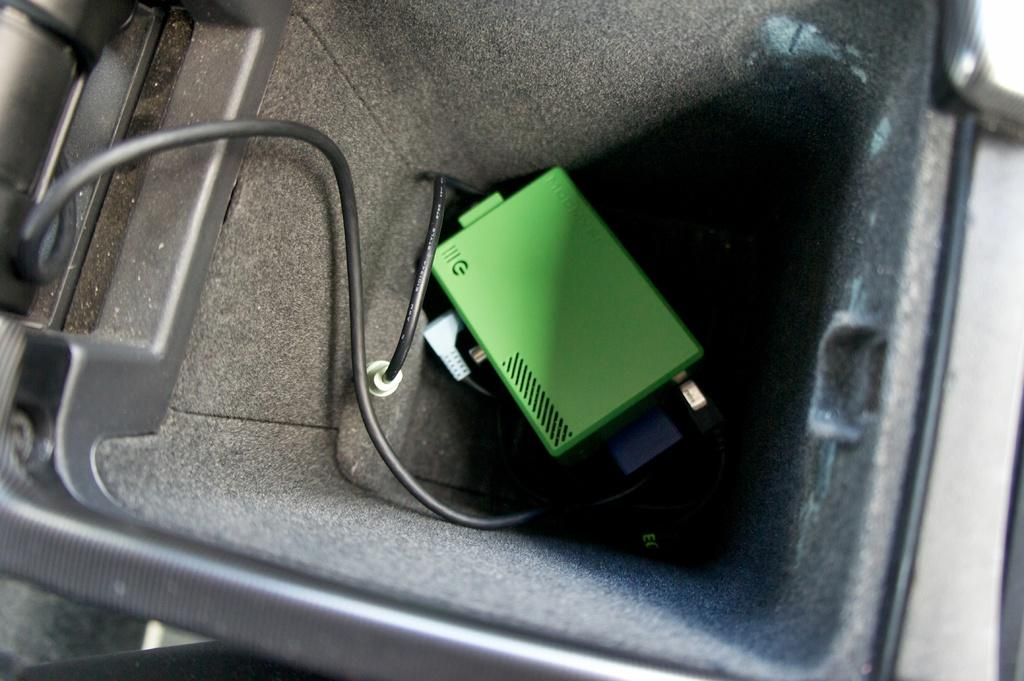What color is the object that is visible in the image? The object in the image is green. How is the green object contained or held in the image? The green object is placed in a square-shaped container. What type of items can be seen in the image besides the green object? There are cables in the image. How does the green object grow in the image? The green object does not grow in the image; it is a static object placed in a container. What type of magic is being performed with the green object in the image? There is no magic or any indication of magical activity in the image. 